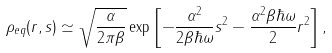Convert formula to latex. <formula><loc_0><loc_0><loc_500><loc_500>\rho _ { e q } ( r , s ) \simeq \sqrt { \frac { \alpha } { 2 \pi \beta } } \exp \left [ - \frac { \alpha ^ { 2 } } { 2 \beta \hbar { \omega } } s ^ { 2 } - \frac { \alpha ^ { 2 } \beta \hbar { \omega } } { 2 } r ^ { 2 } \right ] ,</formula> 